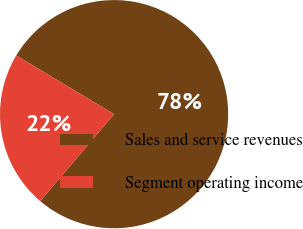<chart> <loc_0><loc_0><loc_500><loc_500><pie_chart><fcel>Sales and service revenues<fcel>Segment operating income<nl><fcel>77.61%<fcel>22.39%<nl></chart> 